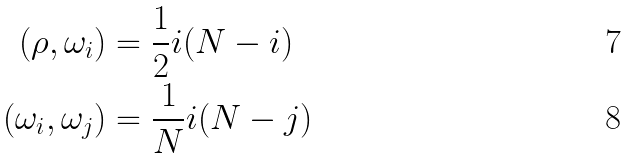<formula> <loc_0><loc_0><loc_500><loc_500>( \rho , \omega _ { i } ) & = \frac { 1 } { 2 } i ( N - i ) \\ ( \omega _ { i } , \omega _ { j } ) & = \frac { 1 } { N } i ( N - j )</formula> 